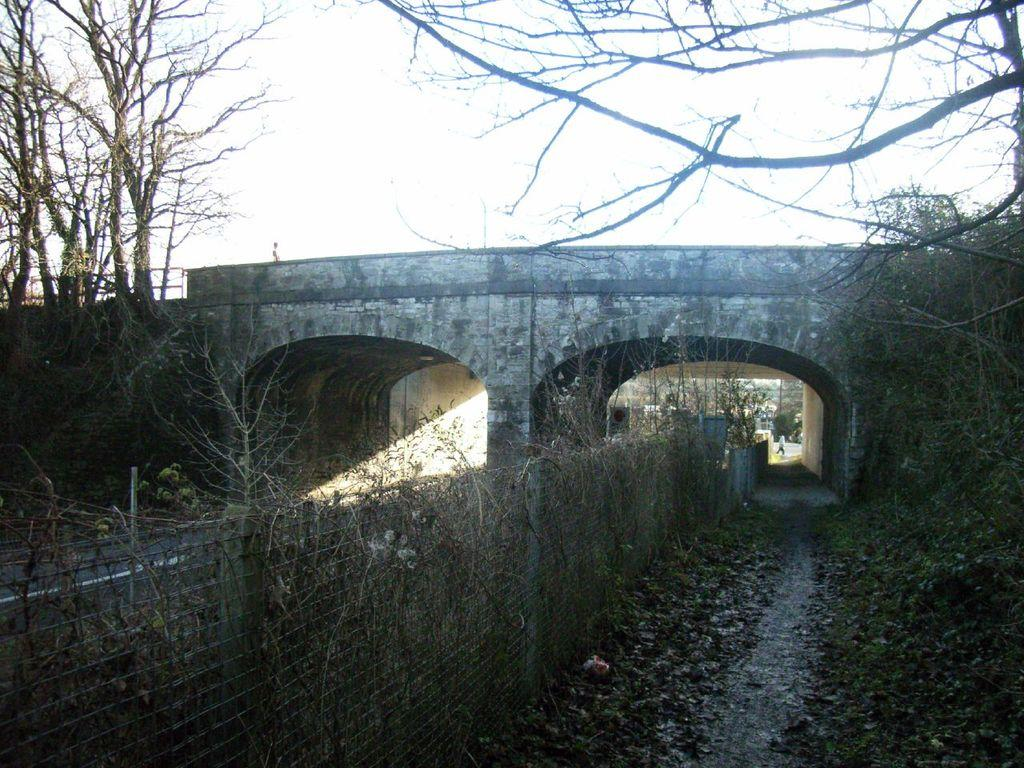What structure can be seen in the image? There is a wall in the image. What is located in the middle of the image? There appears to be a bridge in the middle of the image. What type of vegetation is present on either side of the image? There are trees on either side of the image. What is visible at the top of the image? The sky is visible at the top of the image. How many crows are sitting on the wall in the image? There are no crows present in the image. What type of mark can be seen on the bridge in the image? There is no mark visible on the bridge in the image. 